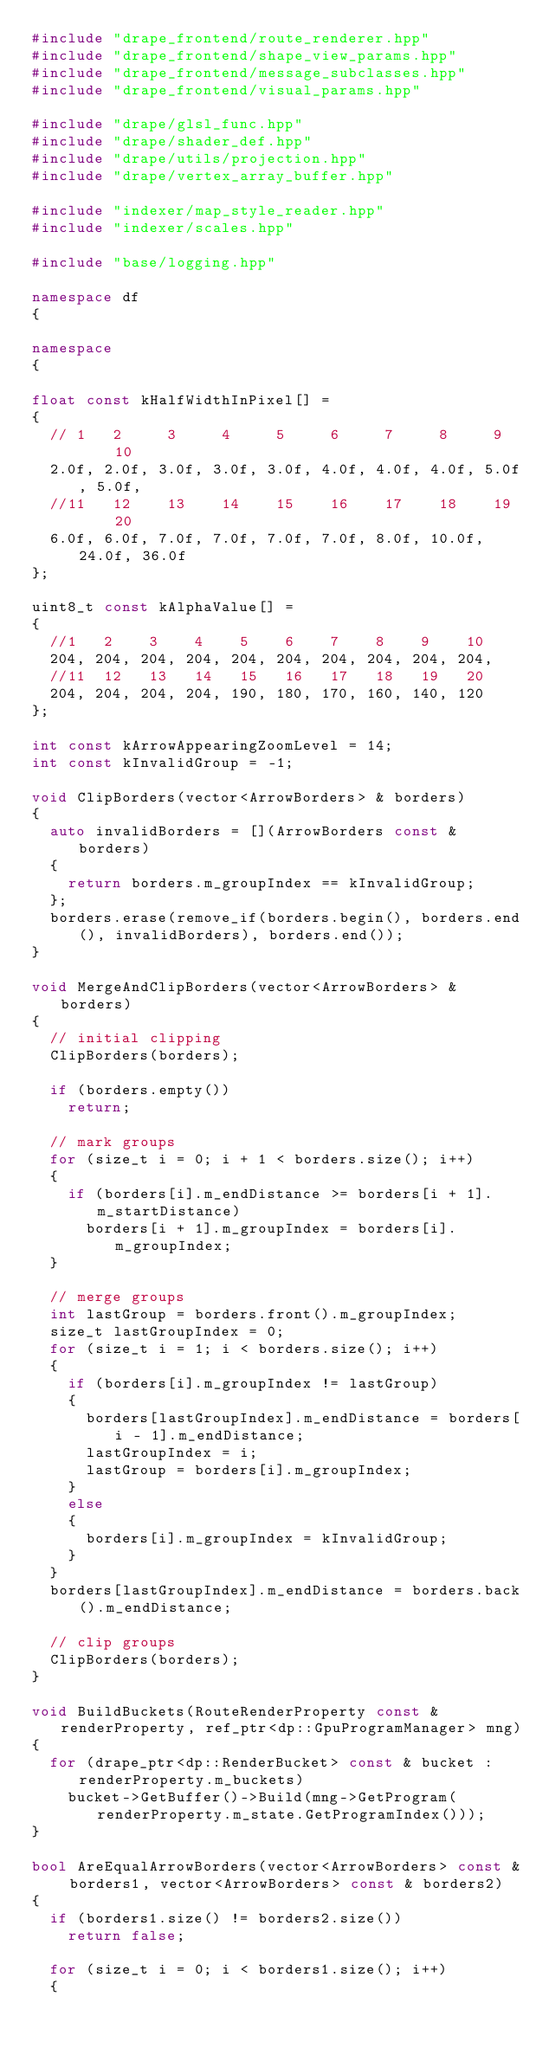Convert code to text. <code><loc_0><loc_0><loc_500><loc_500><_C++_>#include "drape_frontend/route_renderer.hpp"
#include "drape_frontend/shape_view_params.hpp"
#include "drape_frontend/message_subclasses.hpp"
#include "drape_frontend/visual_params.hpp"

#include "drape/glsl_func.hpp"
#include "drape/shader_def.hpp"
#include "drape/utils/projection.hpp"
#include "drape/vertex_array_buffer.hpp"

#include "indexer/map_style_reader.hpp"
#include "indexer/scales.hpp"

#include "base/logging.hpp"

namespace df
{

namespace
{

float const kHalfWidthInPixel[] =
{
  // 1   2     3     4     5     6     7     8     9     10
  2.0f, 2.0f, 3.0f, 3.0f, 3.0f, 4.0f, 4.0f, 4.0f, 5.0f, 5.0f,
  //11   12    13    14    15    16    17    18    19     20
  6.0f, 6.0f, 7.0f, 7.0f, 7.0f, 7.0f, 8.0f, 10.0f, 24.0f, 36.0f
};

uint8_t const kAlphaValue[] =
{
  //1   2    3    4    5    6    7    8    9    10
  204, 204, 204, 204, 204, 204, 204, 204, 204, 204,
  //11  12   13   14   15   16   17   18   19   20
  204, 204, 204, 204, 190, 180, 170, 160, 140, 120
};

int const kArrowAppearingZoomLevel = 14;
int const kInvalidGroup = -1;

void ClipBorders(vector<ArrowBorders> & borders)
{
  auto invalidBorders = [](ArrowBorders const & borders)
  {
    return borders.m_groupIndex == kInvalidGroup;
  };
  borders.erase(remove_if(borders.begin(), borders.end(), invalidBorders), borders.end());
}

void MergeAndClipBorders(vector<ArrowBorders> & borders)
{
  // initial clipping
  ClipBorders(borders);

  if (borders.empty())
    return;

  // mark groups
  for (size_t i = 0; i + 1 < borders.size(); i++)
  {
    if (borders[i].m_endDistance >= borders[i + 1].m_startDistance)
      borders[i + 1].m_groupIndex = borders[i].m_groupIndex;
  }

  // merge groups
  int lastGroup = borders.front().m_groupIndex;
  size_t lastGroupIndex = 0;
  for (size_t i = 1; i < borders.size(); i++)
  {
    if (borders[i].m_groupIndex != lastGroup)
    {
      borders[lastGroupIndex].m_endDistance = borders[i - 1].m_endDistance;
      lastGroupIndex = i;
      lastGroup = borders[i].m_groupIndex;
    }
    else
    {
      borders[i].m_groupIndex = kInvalidGroup;
    }
  }
  borders[lastGroupIndex].m_endDistance = borders.back().m_endDistance;

  // clip groups
  ClipBorders(borders);
}

void BuildBuckets(RouteRenderProperty const & renderProperty, ref_ptr<dp::GpuProgramManager> mng)
{
  for (drape_ptr<dp::RenderBucket> const & bucket : renderProperty.m_buckets)
    bucket->GetBuffer()->Build(mng->GetProgram(renderProperty.m_state.GetProgramIndex()));
}

bool AreEqualArrowBorders(vector<ArrowBorders> const & borders1, vector<ArrowBorders> const & borders2)
{
  if (borders1.size() != borders2.size())
    return false;

  for (size_t i = 0; i < borders1.size(); i++)
  {</code> 